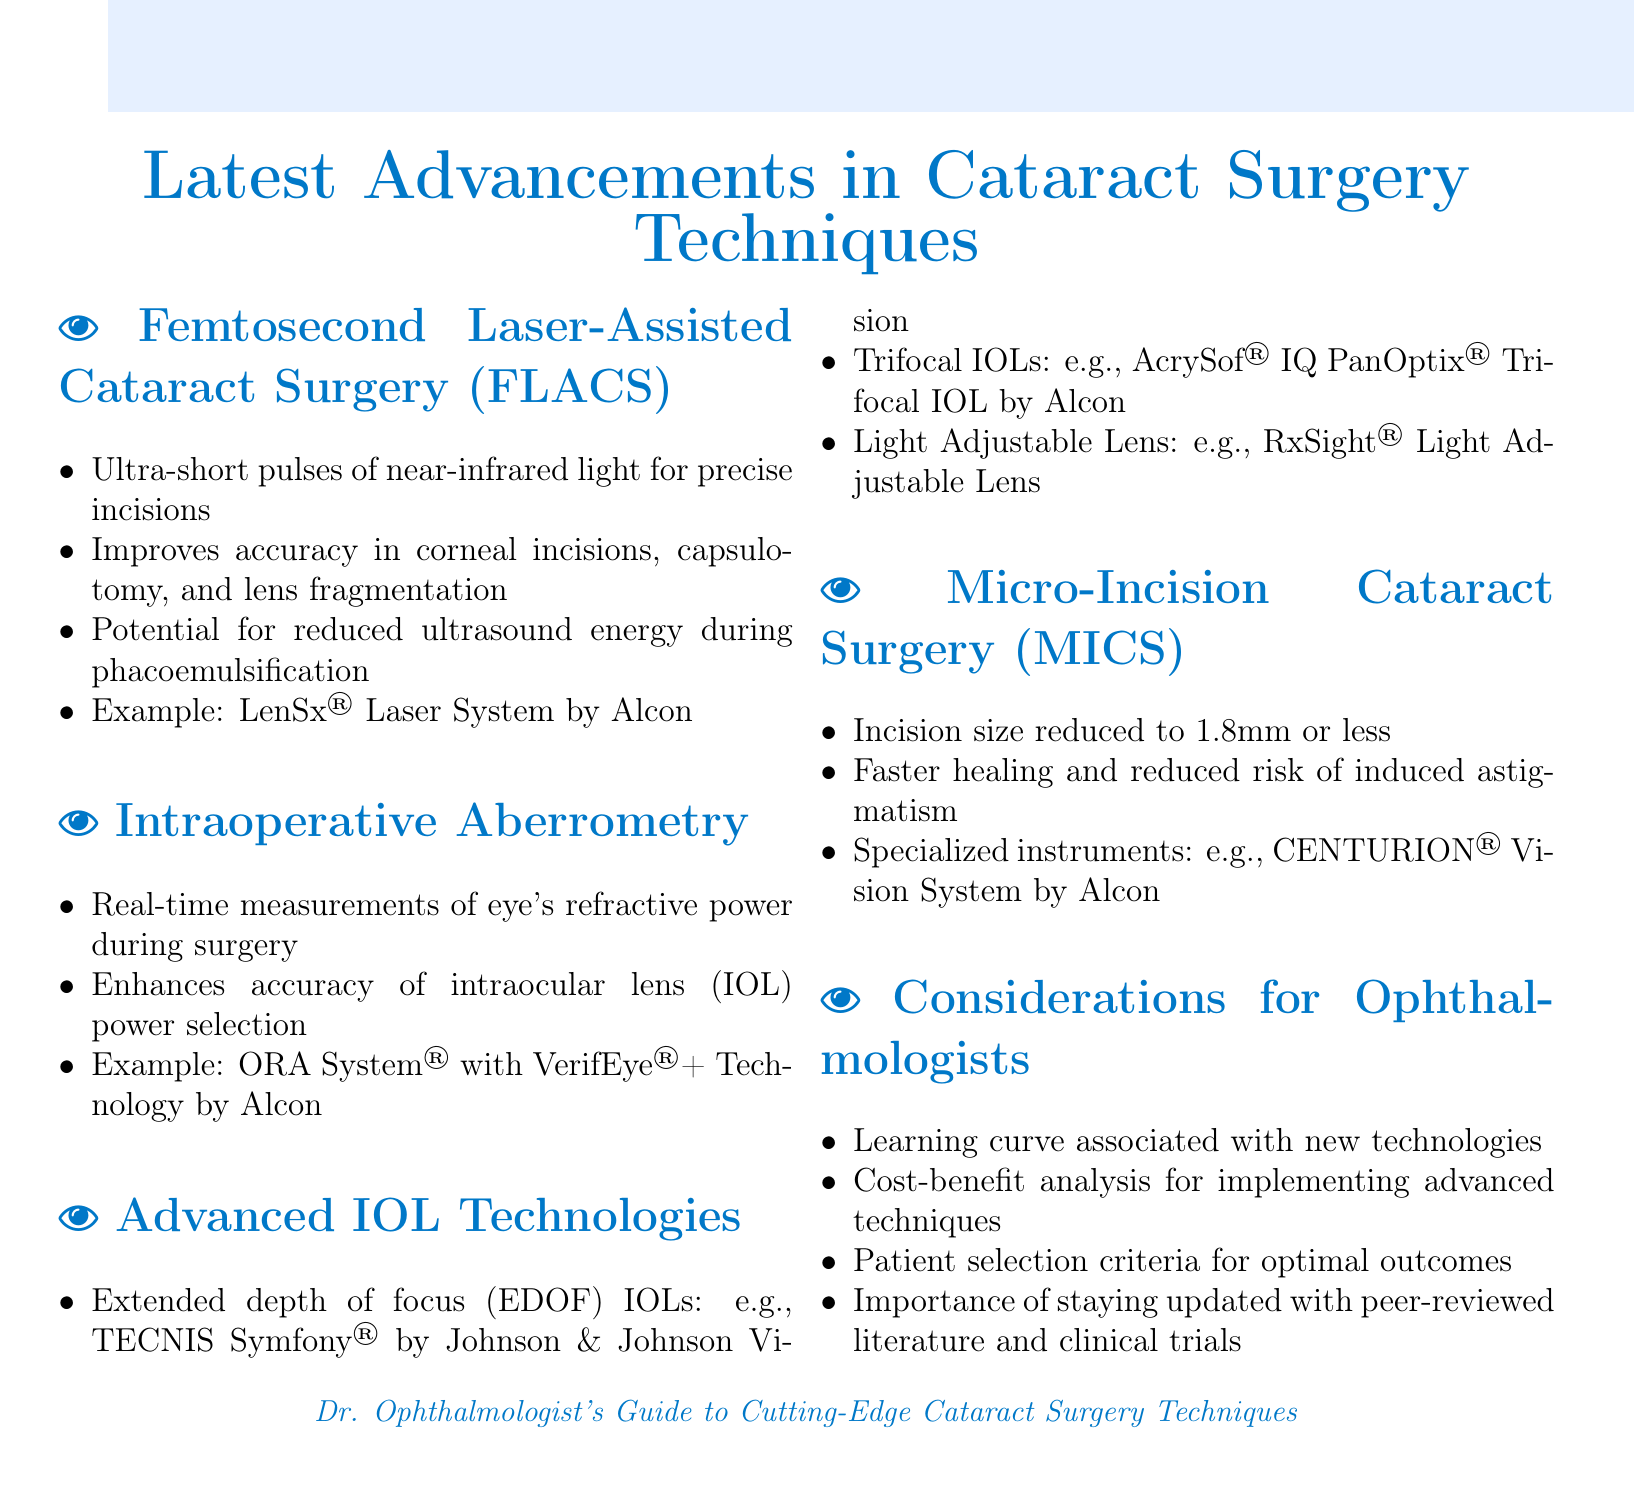What is the laser system used in femtosecond laser-assisted cataract surgery? The document mentions the LenSx® Laser System by Alcon as an example of a laser system used in femtosecond laser-assisted cataract surgery.
Answer: LenSx® Laser System by Alcon What size is the incision in Micro-Incision Cataract Surgery? The document states that the incision size is reduced to 1.8mm or less in Micro-Incision Cataract Surgery.
Answer: 1.8mm or less What technology enhances the accuracy of IOL power selection during surgery? The document identifies the ORA System® with VerifEye®+ Technology by Alcon as a technology that enhances the accuracy of IOL power selection during surgery.
Answer: ORA System® with VerifEye®+ Technology by Alcon What effect does femtosecond laser-assisted cataract surgery have on ultrasound energy usage? The document notes that there is potential for reduced ultrasound energy during phacoemulsification when using femtosecond laser-assisted cataract surgery.
Answer: Reduced ultrasound energy What is an example of an extended depth of focus IOL? The document provides TECNIS Symfony® by Johnson & Johnson Vision as an example of an extended depth of focus IOL.
Answer: TECNIS Symfony® by Johnson & Johnson Vision What is a consideration for ophthalmologists when using advanced techniques? The document lists several considerations, including the learning curve associated with new technologies.
Answer: Learning curve How do micro-incision cataract surgeries affect healing? The document states that micro-incision cataract surgeries lead to faster healing and reduced risk of induced astigmatism.
Answer: Faster healing What kind of lenses does the Light Adjustable Lens technology provide? The Light Adjustable Lens is mentioned in the document as part of advanced IOL technologies.
Answer: Light Adjustable Lens 